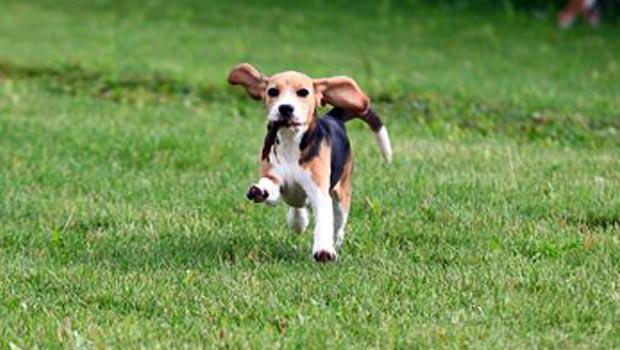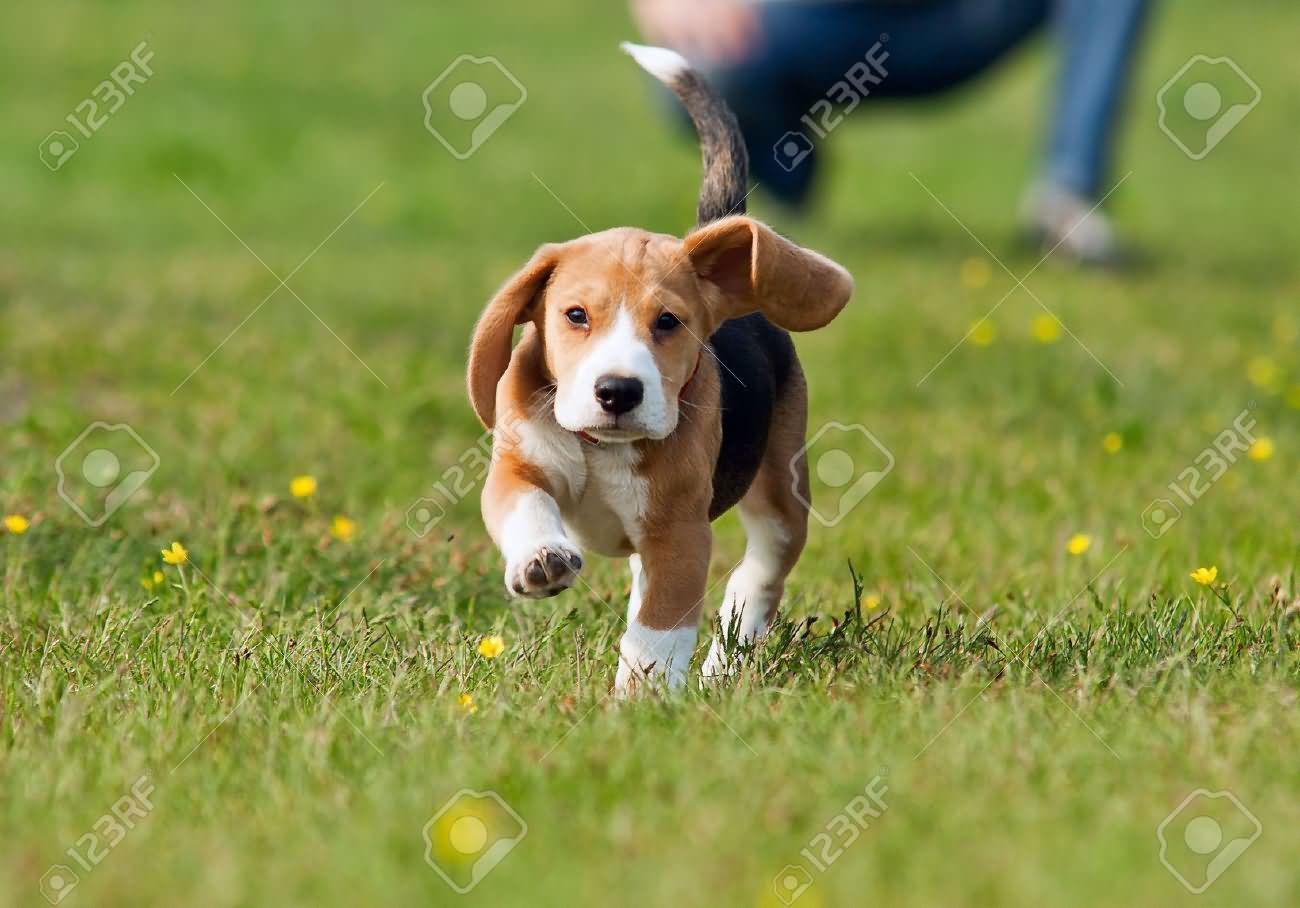The first image is the image on the left, the second image is the image on the right. Analyze the images presented: Is the assertion "Both images in the pair contain only one dog." valid? Answer yes or no. Yes. The first image is the image on the left, the second image is the image on the right. Examine the images to the left and right. Is the description "There are no more than two puppies." accurate? Answer yes or no. Yes. 